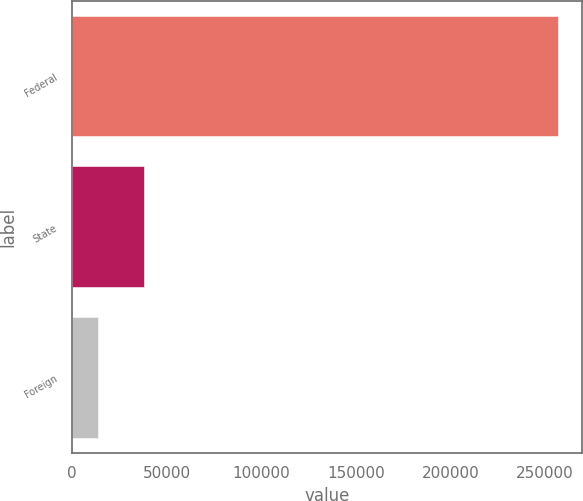Convert chart. <chart><loc_0><loc_0><loc_500><loc_500><bar_chart><fcel>Federal<fcel>State<fcel>Foreign<nl><fcel>256748<fcel>37984.1<fcel>13677<nl></chart> 